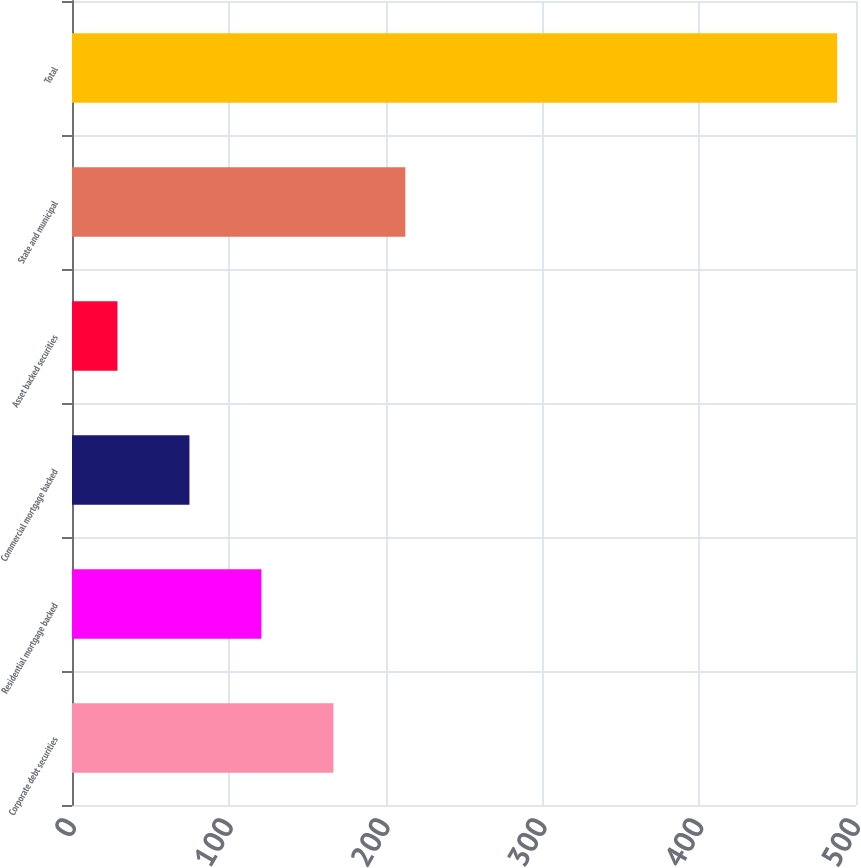Convert chart. <chart><loc_0><loc_0><loc_500><loc_500><bar_chart><fcel>Corporate debt securities<fcel>Residential mortgage backed<fcel>Commercial mortgage backed<fcel>Asset backed securities<fcel>State and municipal<fcel>Total<nl><fcel>166.7<fcel>120.8<fcel>74.9<fcel>29<fcel>212.6<fcel>488<nl></chart> 